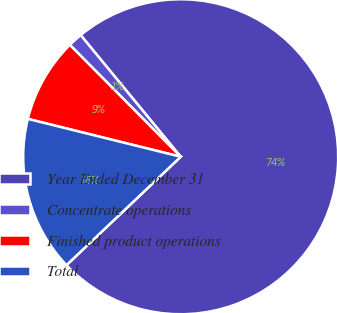Convert chart. <chart><loc_0><loc_0><loc_500><loc_500><pie_chart><fcel>Year Ended December 31<fcel>Concentrate operations<fcel>Finished product operations<fcel>Total<nl><fcel>73.88%<fcel>1.47%<fcel>8.71%<fcel>15.95%<nl></chart> 